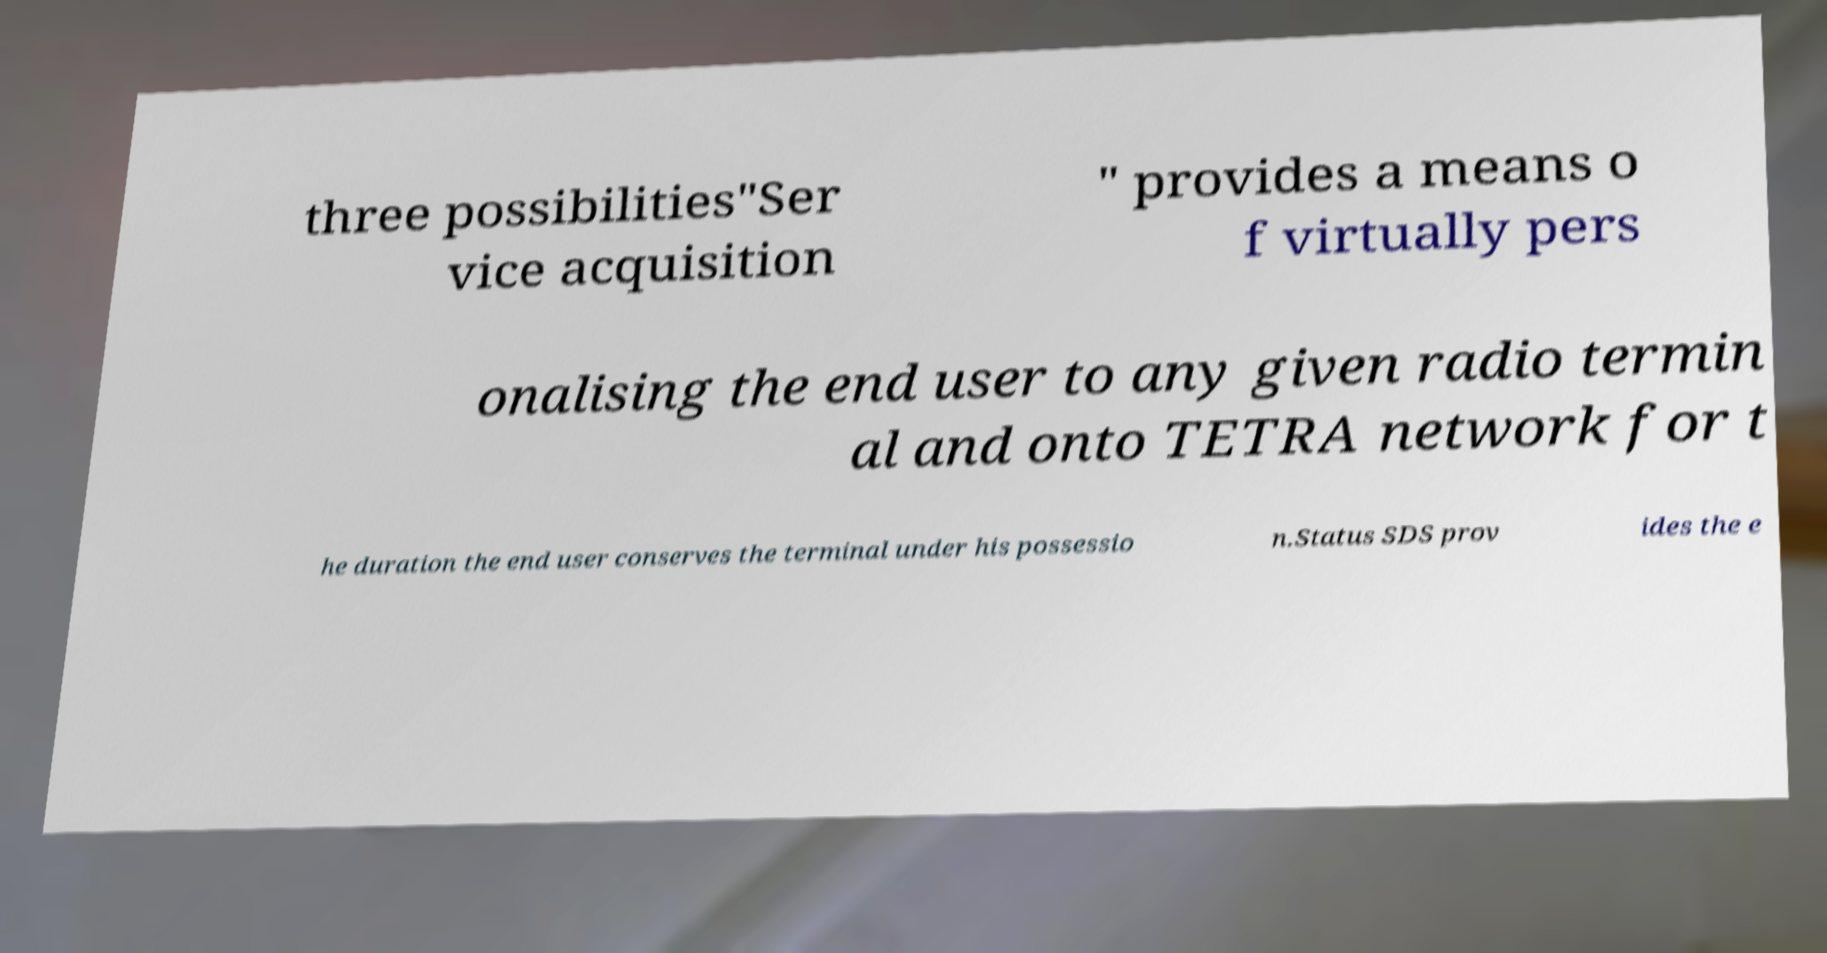Can you read and provide the text displayed in the image?This photo seems to have some interesting text. Can you extract and type it out for me? three possibilities"Ser vice acquisition " provides a means o f virtually pers onalising the end user to any given radio termin al and onto TETRA network for t he duration the end user conserves the terminal under his possessio n.Status SDS prov ides the e 